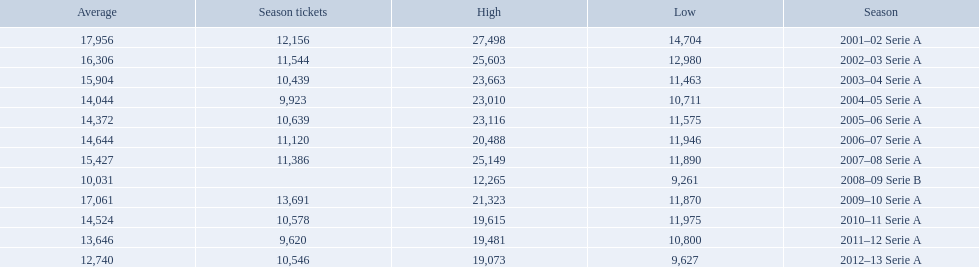What seasons were played at the stadio ennio tardini 2001–02 Serie A, 2002–03 Serie A, 2003–04 Serie A, 2004–05 Serie A, 2005–06 Serie A, 2006–07 Serie A, 2007–08 Serie A, 2008–09 Serie B, 2009–10 Serie A, 2010–11 Serie A, 2011–12 Serie A, 2012–13 Serie A. Which of these seasons had season tickets? 2001–02 Serie A, 2002–03 Serie A, 2003–04 Serie A, 2004–05 Serie A, 2005–06 Serie A, 2006–07 Serie A, 2007–08 Serie A, 2009–10 Serie A, 2010–11 Serie A, 2011–12 Serie A, 2012–13 Serie A. How many season tickets did the 2007-08 season have? 11,386. 